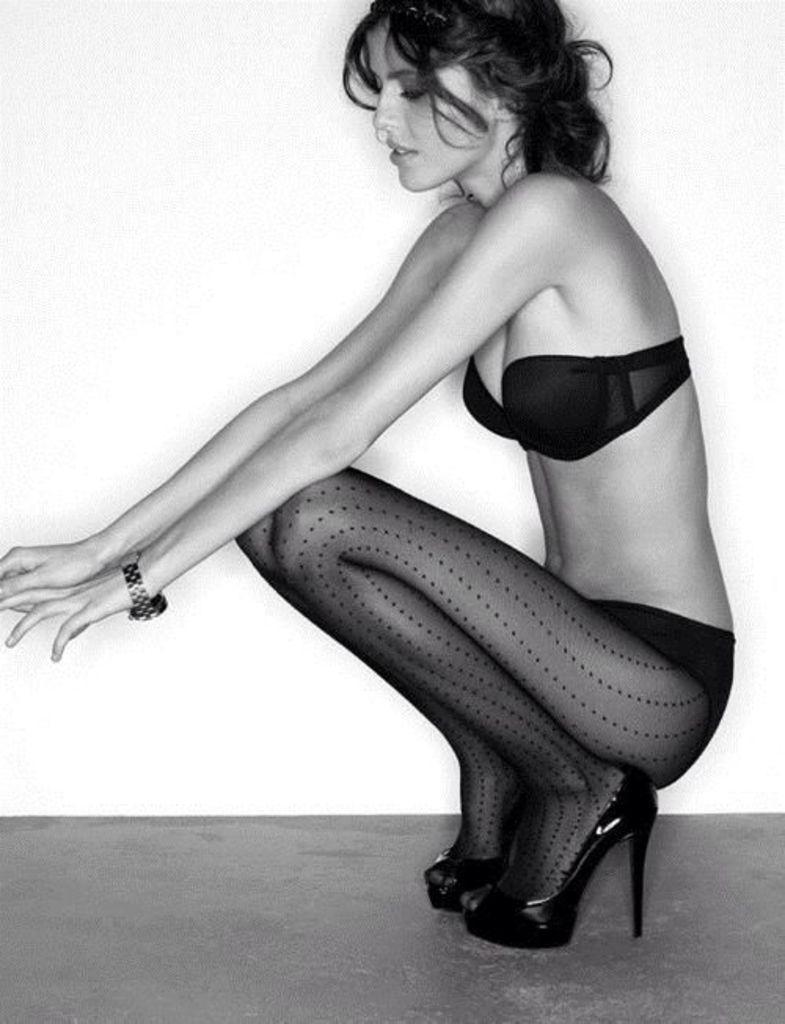Can you describe this image briefly? In the image we can see a woman wearing inner wear, sandal and a wrist watch. 